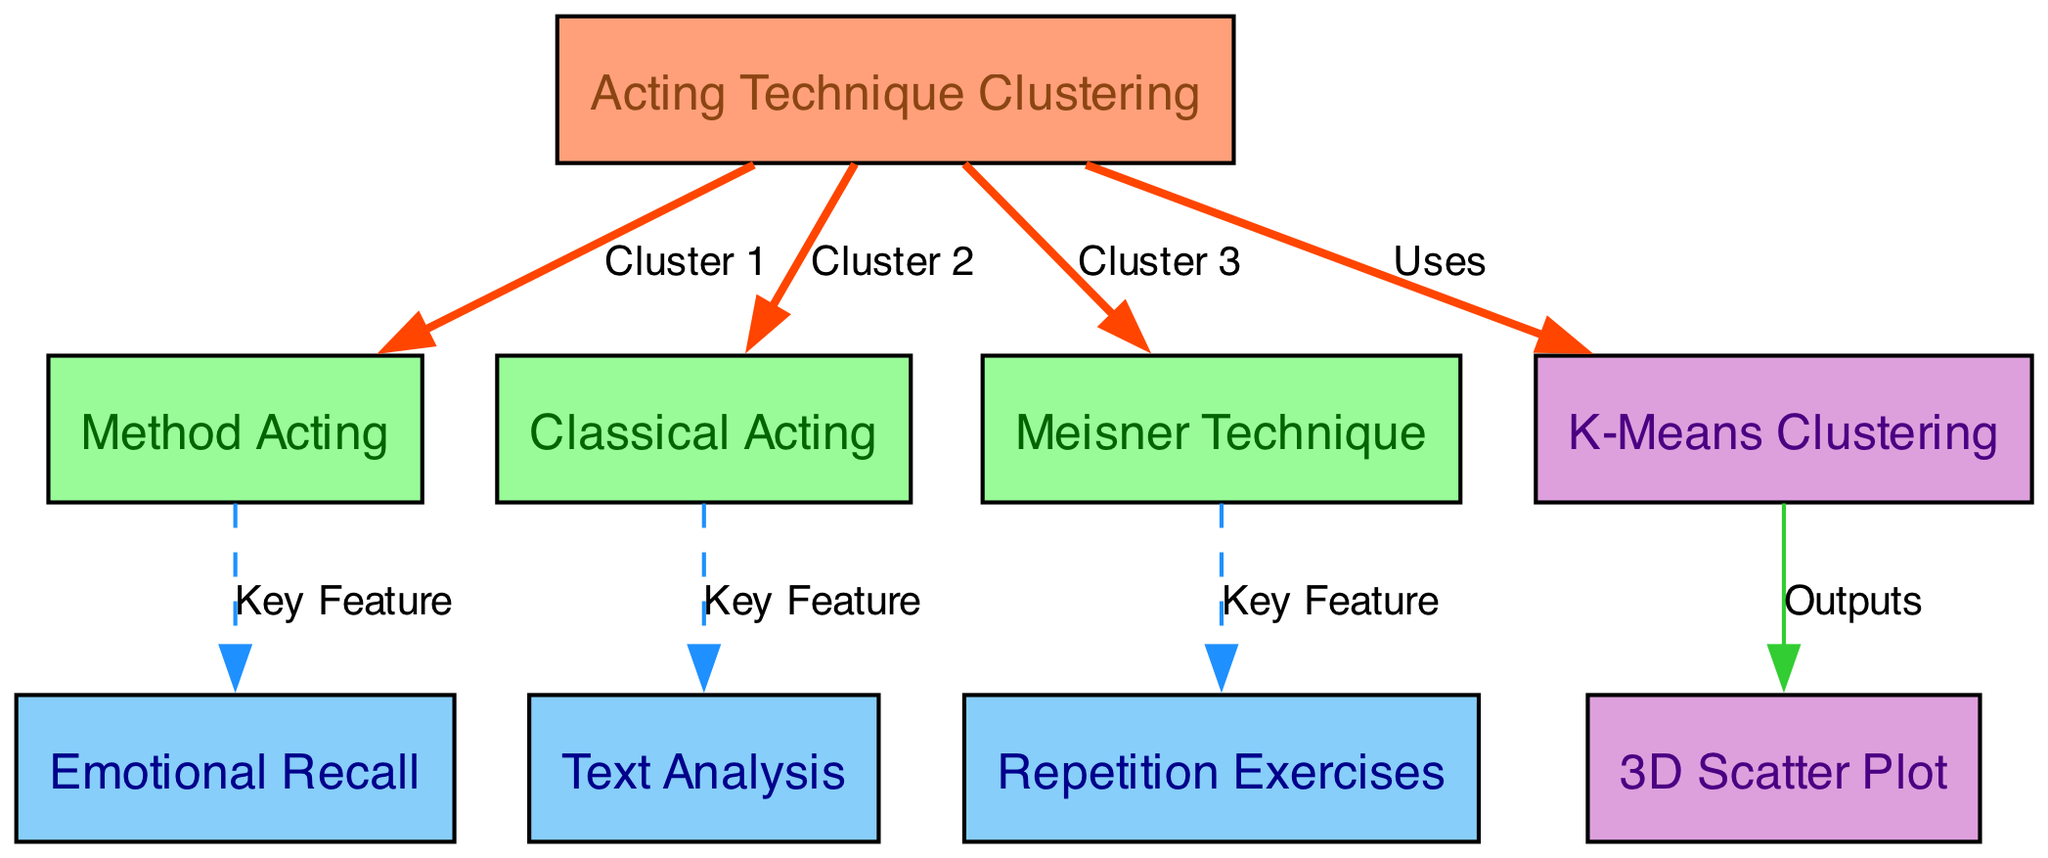What are the three clusters in the diagram? The diagram shows three clusters connected to the root node: Method Acting, Classical Acting, and Meisner Technique. Each cluster is represented by a different method node.
Answer: Method Acting, Classical Acting, Meisner Technique What key feature is associated with Method Acting? The edge from Method Acting to Emotional Recall is labeled as "Key Feature," indicating that Emotional Recall is the primary feature for this method.
Answer: Emotional Recall How many total nodes are present in the diagram? By counting all unique nodes listed under the "nodes" section, we find there are eight distinct nodes (root, three methods, three features, and one algorithm).
Answer: Eight Which method is linked to Text Analysis? The edge flowing from Classical Acting to Text Analysis indicates that this method is characterized by Text Analysis as its key feature.
Answer: Classical Acting What type of algorithm is used in this diagram? The algorithm node connected to the root is labeled "K-Means Clustering," specifying the clustering technique employed in this diagram.
Answer: K-Means Clustering Which key feature is linked to Meisner Technique? According to the edge connecting the Meisner Technique node to Repetition Exercises, this indicates that Repetition Exercises is a key feature of the Meisner Technique.
Answer: Repetition Exercises What output visualization is generated from the clustering algorithm? The edge going from K-Means Clustering to the 3D Scatter Plot node signifies that the output of the algorithm is represented as a 3D scatter plot.
Answer: 3D Scatter Plot How does the algorithm connect to the root node? The algorithm node has a direct edge labeled "Uses" connecting it to the root node, indicating that the algorithm is utilized within the main clustering framework of the diagram.
Answer: Uses 